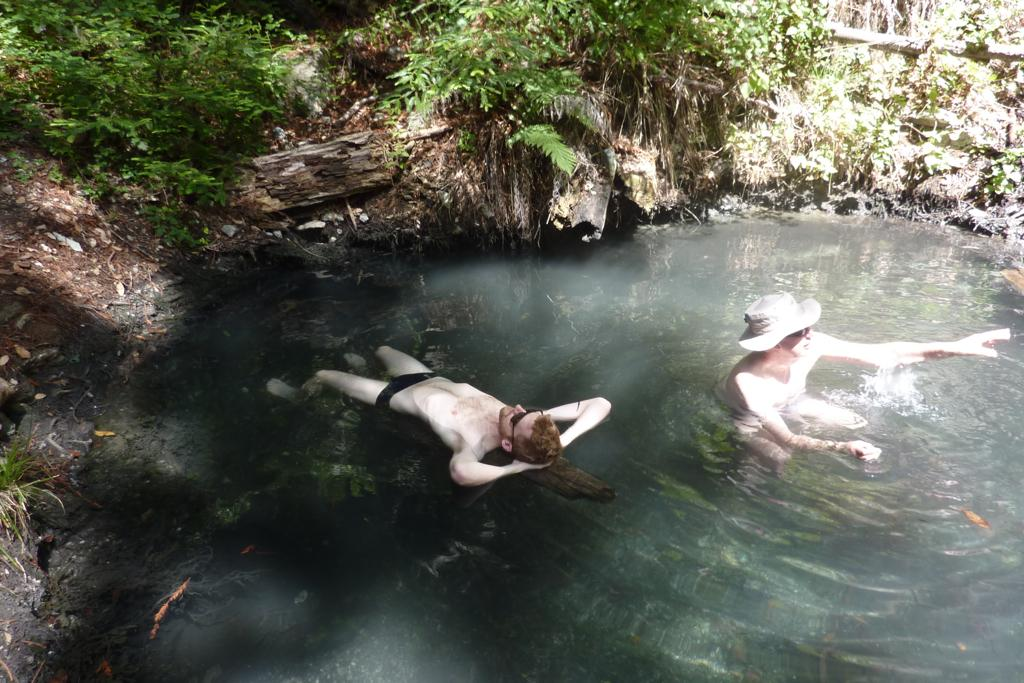What are the people in the image doing? The people in the image are in the water. What is the primary element in the image? Water is visible in the image. Can you describe the person on the right side of the image? There is a person wearing a hat on the right side of the image. What type of vegetation is present in the image? There are many plants in the image. Is there a loud alarm sounding in the image? There is no alarm present in the image. Can you describe the intensity of the rainstorm in the image? There is no rainstorm present in the image; it features people in the water and plants. 